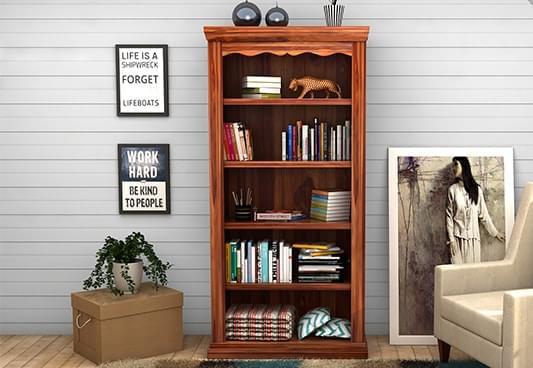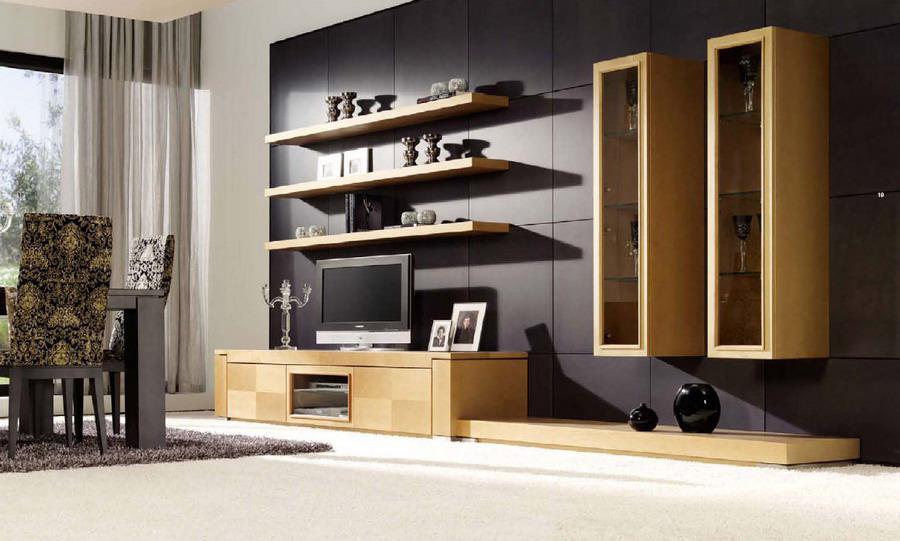The first image is the image on the left, the second image is the image on the right. Analyze the images presented: Is the assertion "IN at least one image there is a free floating shelving." valid? Answer yes or no. Yes. The first image is the image on the left, the second image is the image on the right. For the images displayed, is the sentence "A shelving unit is attached to the wall." factually correct? Answer yes or no. Yes. 